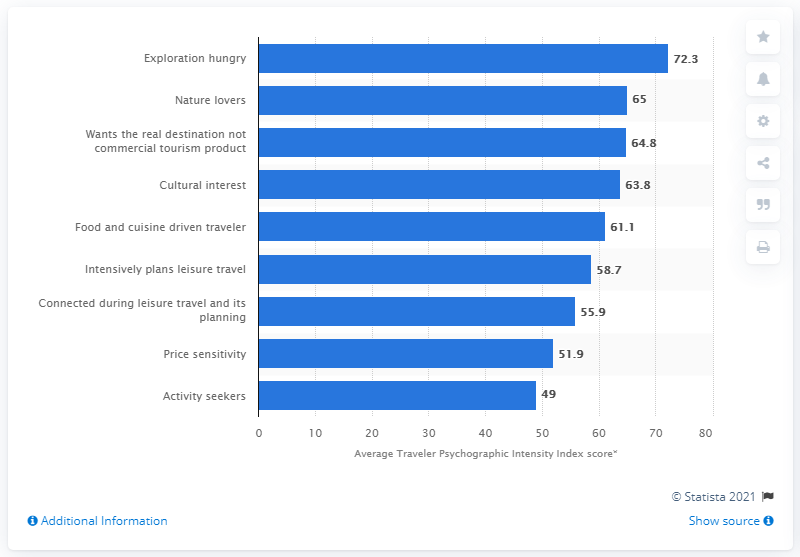Indicate a few pertinent items in this graphic. The average Traveler Psychographic Intensity Index score for Baby Boomers is 72.3. 